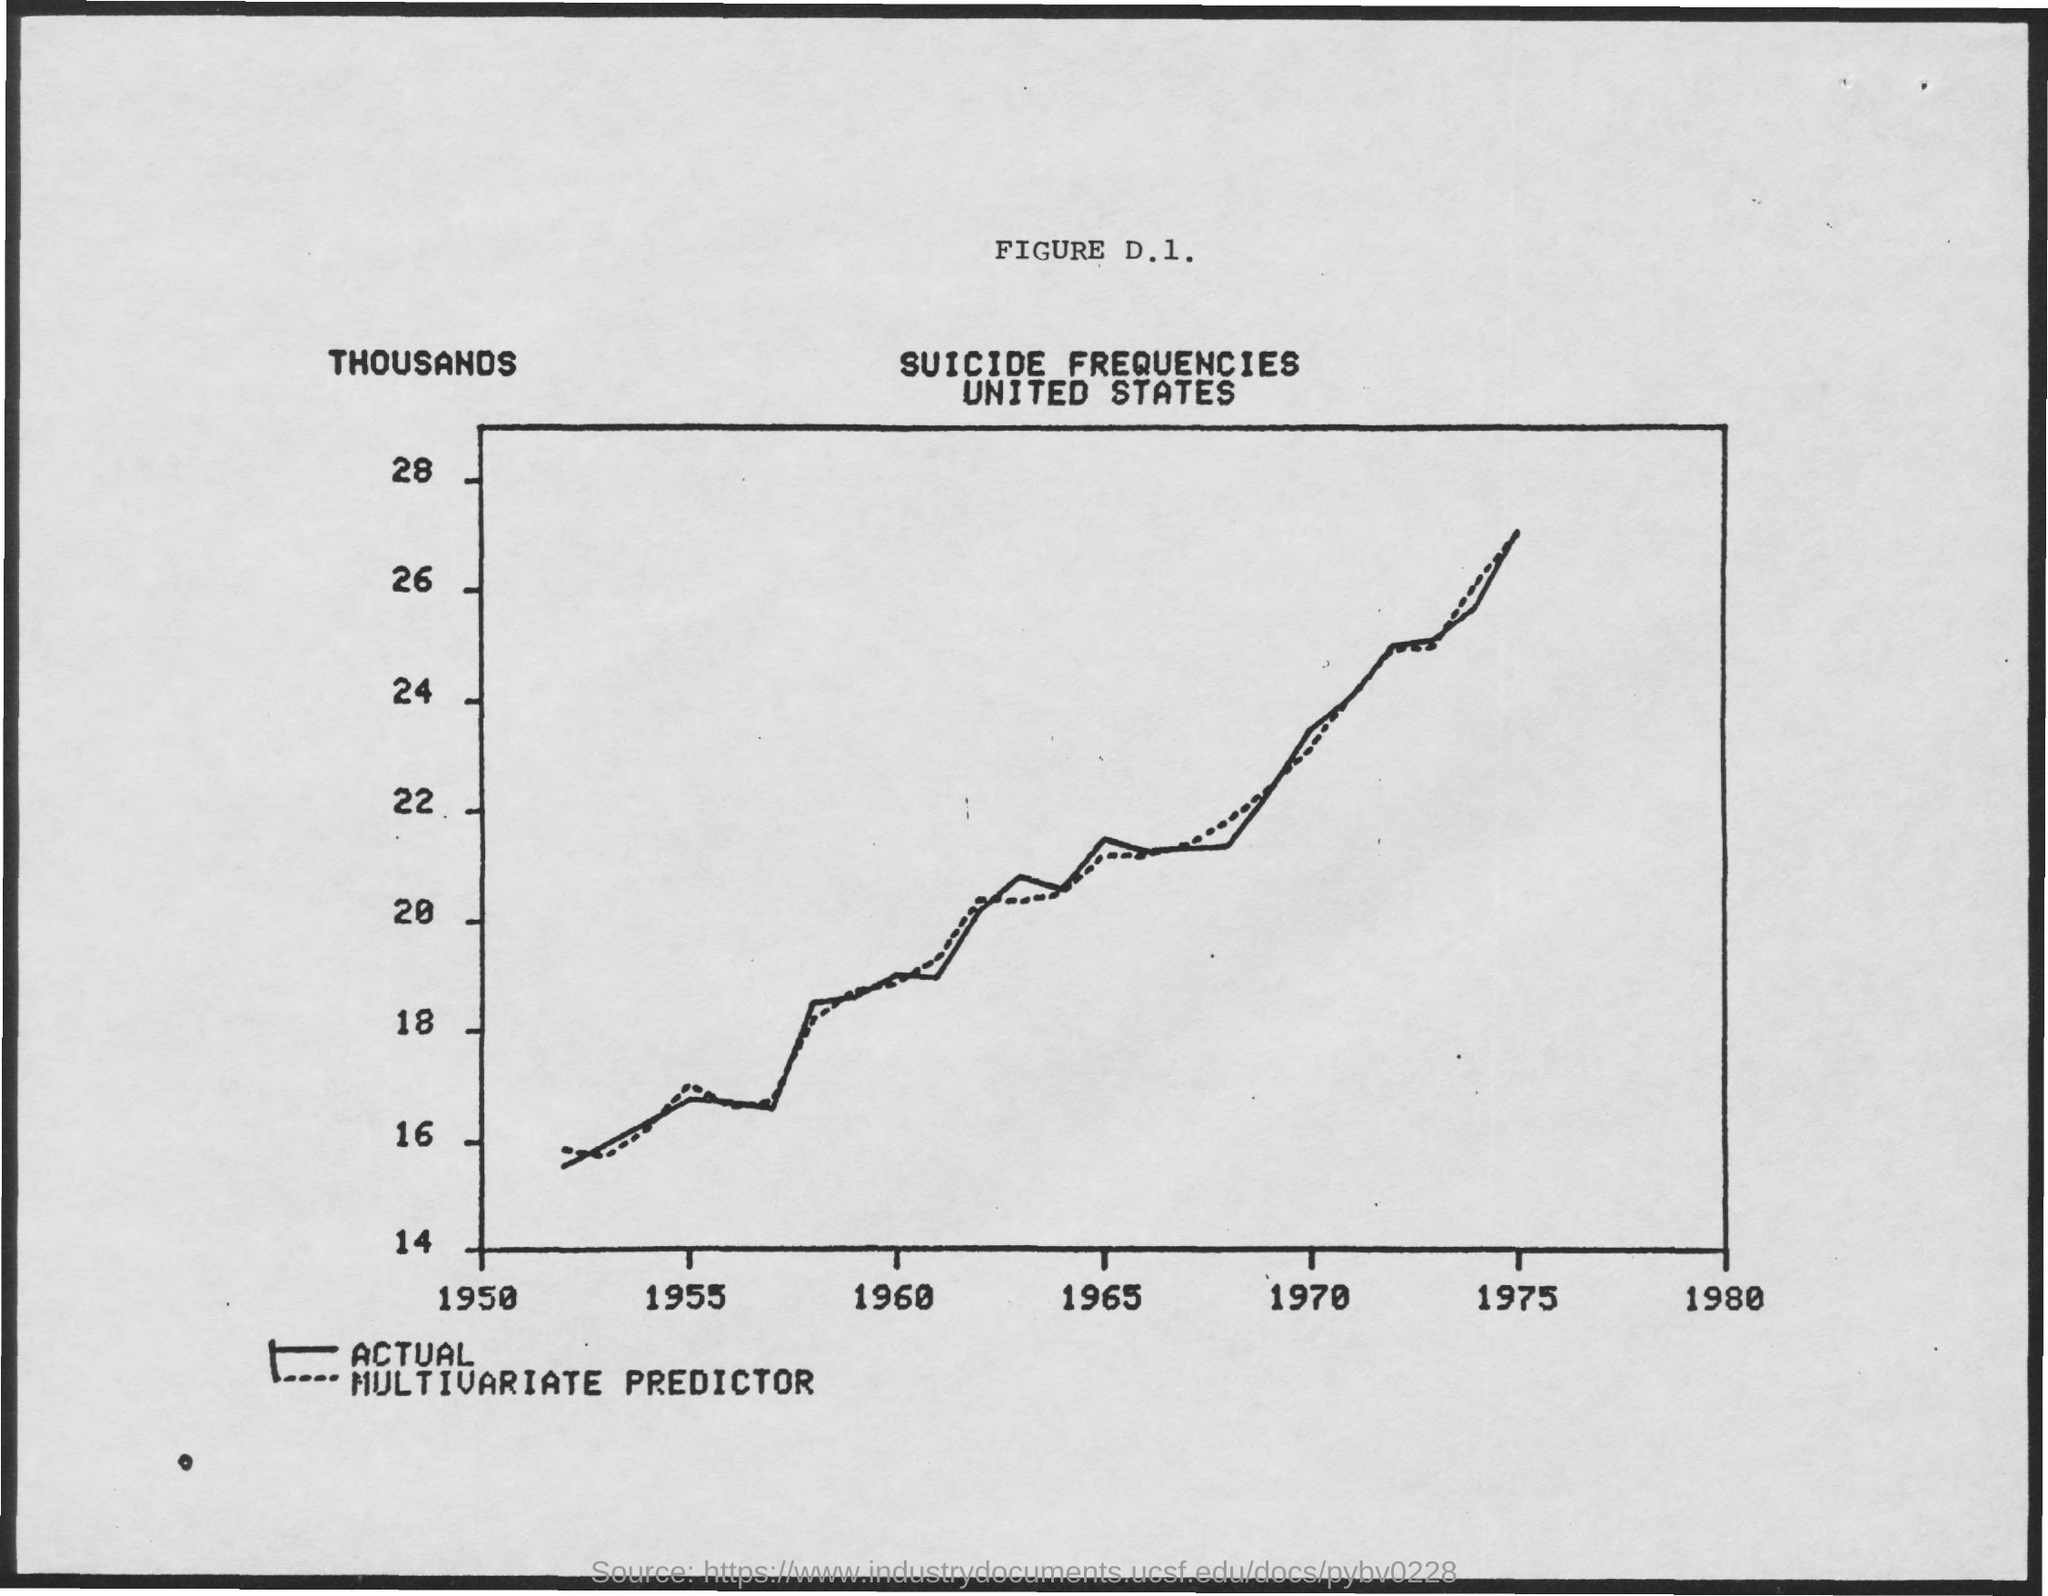What is the graph title?
Your answer should be very brief. Suicide frequencies united states. 